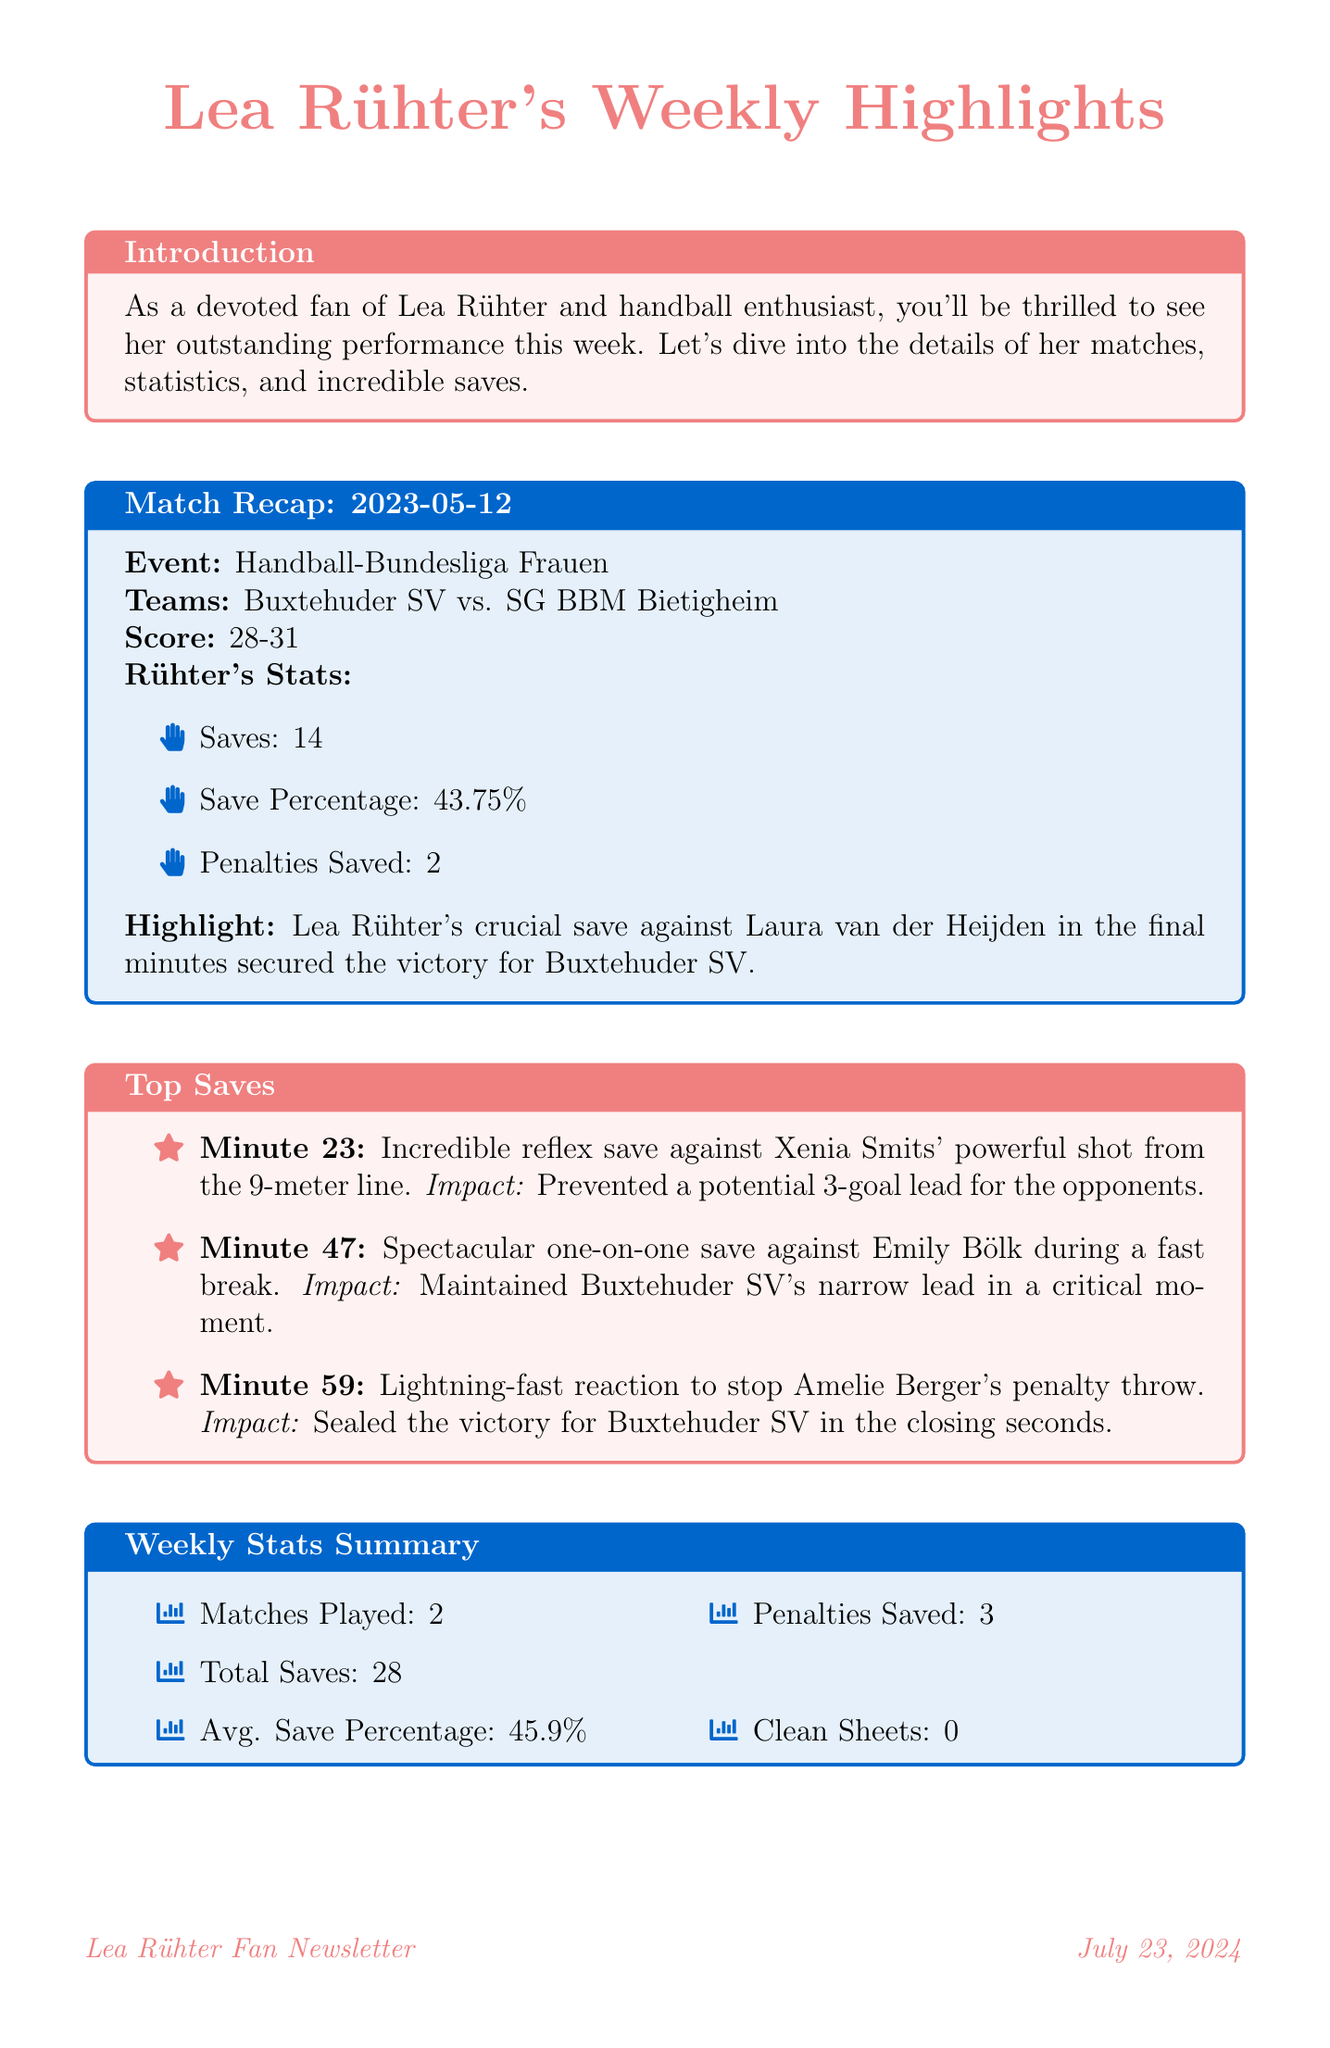What was the final score of the match on May 12? The final score of the match was 28-31, as mentioned in the match recap section.
Answer: 28-31 How many saves did Lea Rühter make in total this week? The total saves this week were added together from her match performances, which amounts to 28 saves in total.
Answer: 28 What is Lea Rühter’s average save percentage? The average save percentage is calculated and stated in the weekly stats summary as 45.9 percent.
Answer: 45.9% What was the important save made by Lea in the final minutes? The document highlights that Lea made a crucial save against Laura van der Heijden in the final minutes of the match.
Answer: Against Laura van der Heijden Who is the coach that made a statement about Lea's performance? The coach's name providing the quote is Dirk Leun, as noted in the coach's corner section.
Answer: Dirk Leun When does Buxtehuder SV play against Thüringer HC? The date for the match against Thüringer HC is listed as May 19, 2023, under upcoming fixtures.
Answer: May 19 What was Lea Rühter's save percentage in the match on May 12? The save percentage for that match is documented as 43.75 percent in the match recap.
Answer: 43.75% What hashtag should fans use to support Lea on social media? The fan corner suggests using the hashtag #RühterRocks for supporting Lea on social media.
Answer: #RühterRocks 